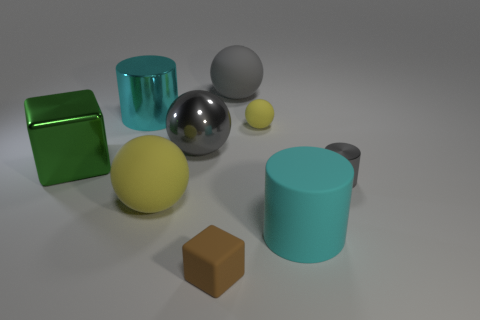There is a large matte cylinder; how many large gray spheres are on the right side of it? 0 